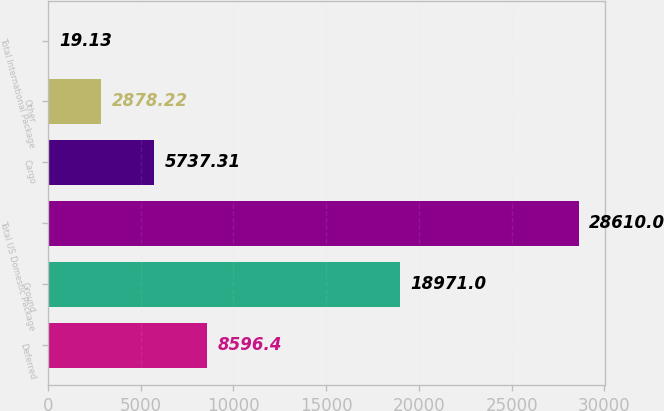Convert chart. <chart><loc_0><loc_0><loc_500><loc_500><bar_chart><fcel>Deferred<fcel>Ground<fcel>Total US Domestic Package<fcel>Cargo<fcel>Other<fcel>Total International Package<nl><fcel>8596.4<fcel>18971<fcel>28610<fcel>5737.31<fcel>2878.22<fcel>19.13<nl></chart> 